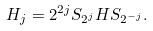Convert formula to latex. <formula><loc_0><loc_0><loc_500><loc_500>H _ { j } = 2 ^ { 2 j } S _ { 2 ^ { j } } H S _ { 2 ^ { - j } } .</formula> 